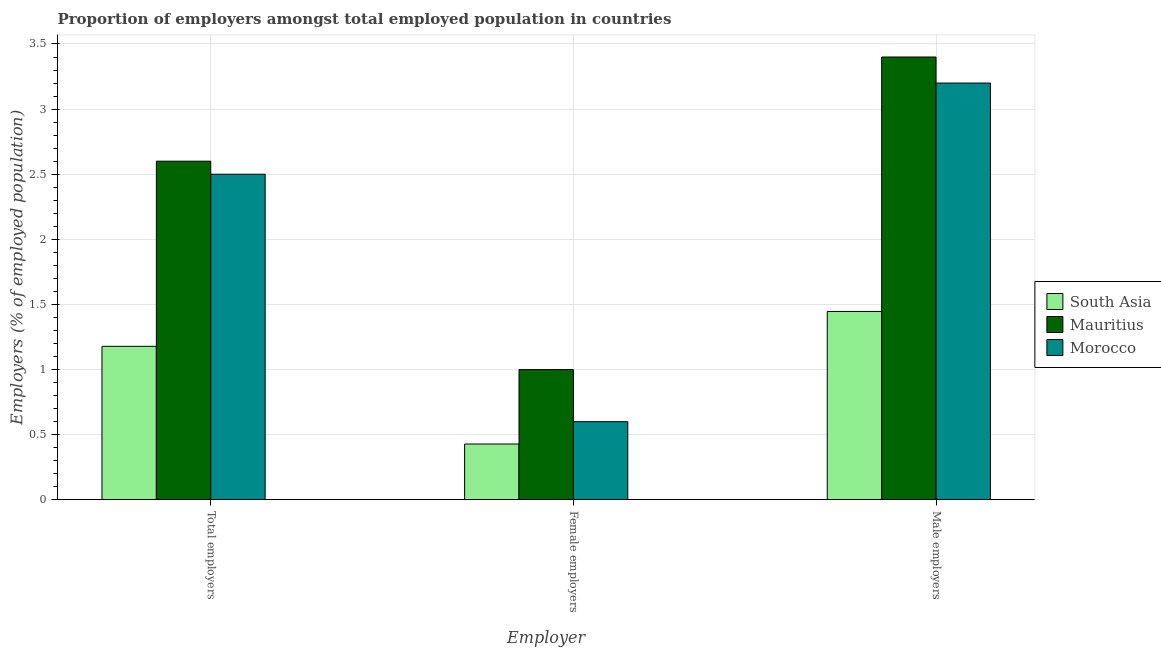How many groups of bars are there?
Your response must be concise. 3. Are the number of bars per tick equal to the number of legend labels?
Provide a succinct answer. Yes. Are the number of bars on each tick of the X-axis equal?
Provide a succinct answer. Yes. How many bars are there on the 1st tick from the left?
Your answer should be very brief. 3. How many bars are there on the 3rd tick from the right?
Offer a terse response. 3. What is the label of the 3rd group of bars from the left?
Offer a very short reply. Male employers. What is the percentage of male employers in Mauritius?
Keep it short and to the point. 3.4. Across all countries, what is the maximum percentage of male employers?
Offer a terse response. 3.4. Across all countries, what is the minimum percentage of male employers?
Make the answer very short. 1.45. In which country was the percentage of total employers maximum?
Offer a terse response. Mauritius. What is the total percentage of total employers in the graph?
Your answer should be compact. 6.28. What is the difference between the percentage of total employers in Mauritius and that in South Asia?
Provide a succinct answer. 1.42. What is the difference between the percentage of total employers in Mauritius and the percentage of female employers in South Asia?
Provide a short and direct response. 2.17. What is the average percentage of male employers per country?
Provide a short and direct response. 2.68. What is the difference between the percentage of female employers and percentage of total employers in South Asia?
Your answer should be very brief. -0.75. In how many countries, is the percentage of female employers greater than 2 %?
Offer a terse response. 0. What is the ratio of the percentage of male employers in South Asia to that in Mauritius?
Offer a terse response. 0.43. Is the percentage of total employers in Mauritius less than that in Morocco?
Keep it short and to the point. No. What is the difference between the highest and the second highest percentage of total employers?
Your response must be concise. 0.1. What is the difference between the highest and the lowest percentage of total employers?
Offer a terse response. 1.42. In how many countries, is the percentage of male employers greater than the average percentage of male employers taken over all countries?
Provide a succinct answer. 2. What does the 1st bar from the left in Total employers represents?
Offer a terse response. South Asia. What does the 1st bar from the right in Male employers represents?
Give a very brief answer. Morocco. Are all the bars in the graph horizontal?
Your answer should be compact. No. How many countries are there in the graph?
Provide a short and direct response. 3. What is the difference between two consecutive major ticks on the Y-axis?
Your answer should be very brief. 0.5. Are the values on the major ticks of Y-axis written in scientific E-notation?
Offer a terse response. No. Does the graph contain grids?
Your answer should be compact. Yes. How are the legend labels stacked?
Keep it short and to the point. Vertical. What is the title of the graph?
Your response must be concise. Proportion of employers amongst total employed population in countries. What is the label or title of the X-axis?
Your answer should be very brief. Employer. What is the label or title of the Y-axis?
Give a very brief answer. Employers (% of employed population). What is the Employers (% of employed population) in South Asia in Total employers?
Offer a very short reply. 1.18. What is the Employers (% of employed population) of Mauritius in Total employers?
Make the answer very short. 2.6. What is the Employers (% of employed population) in South Asia in Female employers?
Offer a terse response. 0.43. What is the Employers (% of employed population) in Morocco in Female employers?
Ensure brevity in your answer.  0.6. What is the Employers (% of employed population) of South Asia in Male employers?
Offer a terse response. 1.45. What is the Employers (% of employed population) in Mauritius in Male employers?
Ensure brevity in your answer.  3.4. What is the Employers (% of employed population) in Morocco in Male employers?
Your answer should be very brief. 3.2. Across all Employer, what is the maximum Employers (% of employed population) in South Asia?
Give a very brief answer. 1.45. Across all Employer, what is the maximum Employers (% of employed population) of Mauritius?
Offer a very short reply. 3.4. Across all Employer, what is the maximum Employers (% of employed population) in Morocco?
Offer a terse response. 3.2. Across all Employer, what is the minimum Employers (% of employed population) of South Asia?
Ensure brevity in your answer.  0.43. Across all Employer, what is the minimum Employers (% of employed population) of Mauritius?
Make the answer very short. 1. Across all Employer, what is the minimum Employers (% of employed population) in Morocco?
Provide a short and direct response. 0.6. What is the total Employers (% of employed population) of South Asia in the graph?
Ensure brevity in your answer.  3.05. What is the total Employers (% of employed population) of Mauritius in the graph?
Make the answer very short. 7. What is the total Employers (% of employed population) in Morocco in the graph?
Provide a short and direct response. 6.3. What is the difference between the Employers (% of employed population) of South Asia in Total employers and that in Female employers?
Your answer should be very brief. 0.75. What is the difference between the Employers (% of employed population) of South Asia in Total employers and that in Male employers?
Offer a terse response. -0.27. What is the difference between the Employers (% of employed population) of Mauritius in Total employers and that in Male employers?
Give a very brief answer. -0.8. What is the difference between the Employers (% of employed population) in South Asia in Female employers and that in Male employers?
Provide a succinct answer. -1.02. What is the difference between the Employers (% of employed population) of Morocco in Female employers and that in Male employers?
Your answer should be compact. -2.6. What is the difference between the Employers (% of employed population) in South Asia in Total employers and the Employers (% of employed population) in Mauritius in Female employers?
Ensure brevity in your answer.  0.18. What is the difference between the Employers (% of employed population) of South Asia in Total employers and the Employers (% of employed population) of Morocco in Female employers?
Give a very brief answer. 0.58. What is the difference between the Employers (% of employed population) in Mauritius in Total employers and the Employers (% of employed population) in Morocco in Female employers?
Offer a terse response. 2. What is the difference between the Employers (% of employed population) in South Asia in Total employers and the Employers (% of employed population) in Mauritius in Male employers?
Provide a succinct answer. -2.22. What is the difference between the Employers (% of employed population) of South Asia in Total employers and the Employers (% of employed population) of Morocco in Male employers?
Keep it short and to the point. -2.02. What is the difference between the Employers (% of employed population) of Mauritius in Total employers and the Employers (% of employed population) of Morocco in Male employers?
Offer a very short reply. -0.6. What is the difference between the Employers (% of employed population) of South Asia in Female employers and the Employers (% of employed population) of Mauritius in Male employers?
Ensure brevity in your answer.  -2.97. What is the difference between the Employers (% of employed population) in South Asia in Female employers and the Employers (% of employed population) in Morocco in Male employers?
Your answer should be very brief. -2.77. What is the average Employers (% of employed population) of South Asia per Employer?
Your answer should be very brief. 1.02. What is the average Employers (% of employed population) of Mauritius per Employer?
Your answer should be compact. 2.33. What is the difference between the Employers (% of employed population) in South Asia and Employers (% of employed population) in Mauritius in Total employers?
Your answer should be compact. -1.42. What is the difference between the Employers (% of employed population) of South Asia and Employers (% of employed population) of Morocco in Total employers?
Offer a very short reply. -1.32. What is the difference between the Employers (% of employed population) in Mauritius and Employers (% of employed population) in Morocco in Total employers?
Keep it short and to the point. 0.1. What is the difference between the Employers (% of employed population) in South Asia and Employers (% of employed population) in Mauritius in Female employers?
Offer a very short reply. -0.57. What is the difference between the Employers (% of employed population) of South Asia and Employers (% of employed population) of Morocco in Female employers?
Provide a succinct answer. -0.17. What is the difference between the Employers (% of employed population) in Mauritius and Employers (% of employed population) in Morocco in Female employers?
Provide a short and direct response. 0.4. What is the difference between the Employers (% of employed population) of South Asia and Employers (% of employed population) of Mauritius in Male employers?
Your answer should be compact. -1.95. What is the difference between the Employers (% of employed population) in South Asia and Employers (% of employed population) in Morocco in Male employers?
Your answer should be compact. -1.75. What is the ratio of the Employers (% of employed population) of South Asia in Total employers to that in Female employers?
Ensure brevity in your answer.  2.75. What is the ratio of the Employers (% of employed population) in Mauritius in Total employers to that in Female employers?
Offer a terse response. 2.6. What is the ratio of the Employers (% of employed population) in Morocco in Total employers to that in Female employers?
Ensure brevity in your answer.  4.17. What is the ratio of the Employers (% of employed population) in South Asia in Total employers to that in Male employers?
Offer a terse response. 0.81. What is the ratio of the Employers (% of employed population) in Mauritius in Total employers to that in Male employers?
Keep it short and to the point. 0.76. What is the ratio of the Employers (% of employed population) in Morocco in Total employers to that in Male employers?
Your response must be concise. 0.78. What is the ratio of the Employers (% of employed population) in South Asia in Female employers to that in Male employers?
Give a very brief answer. 0.3. What is the ratio of the Employers (% of employed population) in Mauritius in Female employers to that in Male employers?
Your answer should be very brief. 0.29. What is the ratio of the Employers (% of employed population) of Morocco in Female employers to that in Male employers?
Offer a very short reply. 0.19. What is the difference between the highest and the second highest Employers (% of employed population) of South Asia?
Make the answer very short. 0.27. What is the difference between the highest and the lowest Employers (% of employed population) in South Asia?
Give a very brief answer. 1.02. What is the difference between the highest and the lowest Employers (% of employed population) of Mauritius?
Offer a terse response. 2.4. 